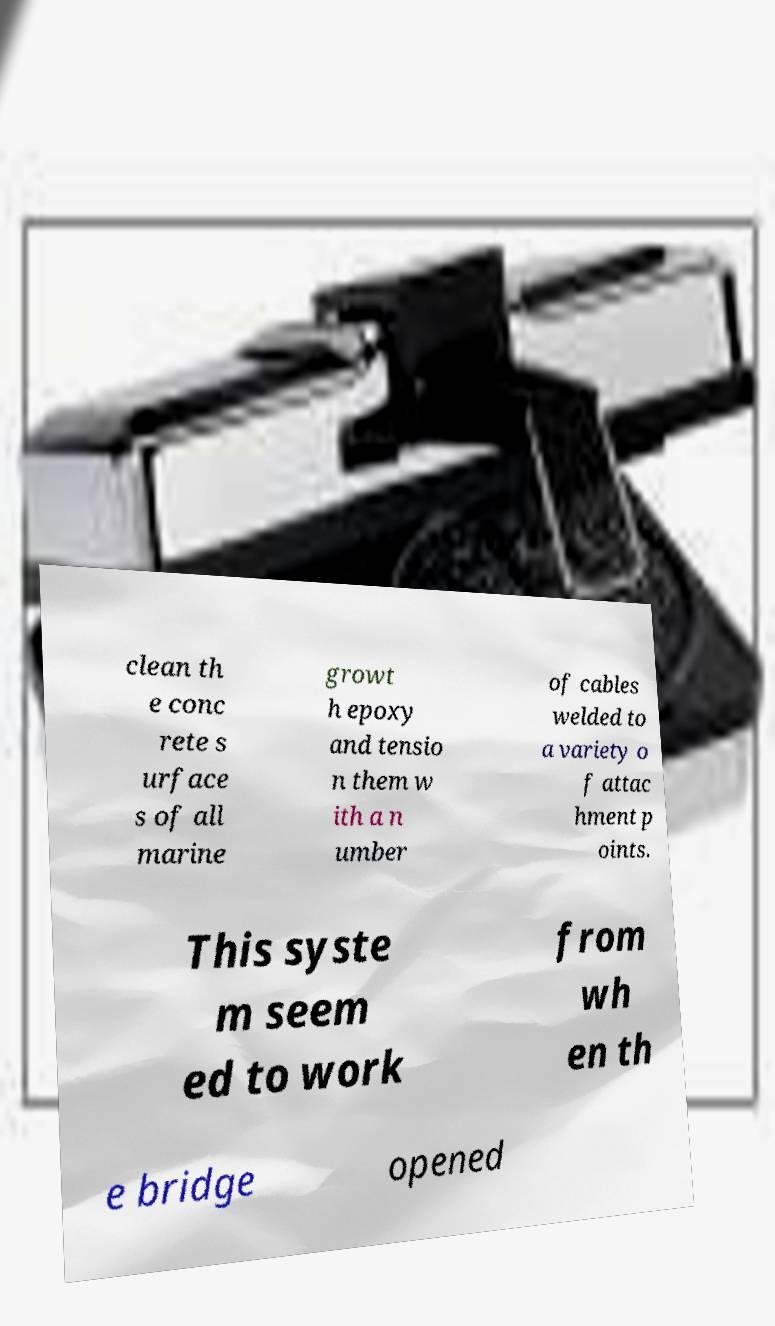Please read and relay the text visible in this image. What does it say? clean th e conc rete s urface s of all marine growt h epoxy and tensio n them w ith a n umber of cables welded to a variety o f attac hment p oints. This syste m seem ed to work from wh en th e bridge opened 